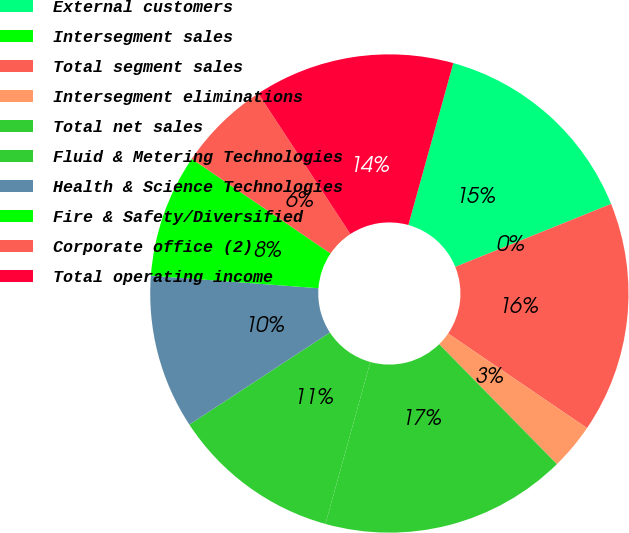Convert chart. <chart><loc_0><loc_0><loc_500><loc_500><pie_chart><fcel>External customers<fcel>Intersegment sales<fcel>Total segment sales<fcel>Intersegment eliminations<fcel>Total net sales<fcel>Fluid & Metering Technologies<fcel>Health & Science Technologies<fcel>Fire & Safety/Diversified<fcel>Corporate office (2)<fcel>Total operating income<nl><fcel>14.58%<fcel>0.0%<fcel>15.62%<fcel>3.13%<fcel>16.66%<fcel>11.46%<fcel>10.42%<fcel>8.33%<fcel>6.25%<fcel>13.54%<nl></chart> 